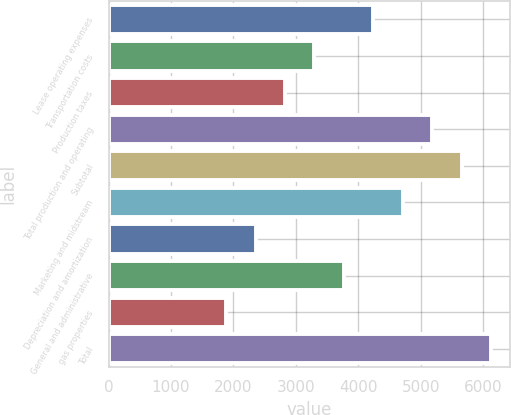Convert chart. <chart><loc_0><loc_0><loc_500><loc_500><bar_chart><fcel>Lease operating expenses<fcel>Transportation costs<fcel>Production taxes<fcel>Total production and operating<fcel>Subtotal<fcel>Marketing and midstream<fcel>Depreciation and amortization<fcel>General and administrative<fcel>gas properties<fcel>Total<nl><fcel>4239.04<fcel>3297.14<fcel>2826.19<fcel>5180.94<fcel>5651.89<fcel>4709.99<fcel>2355.24<fcel>3768.09<fcel>1884.29<fcel>6122.84<nl></chart> 